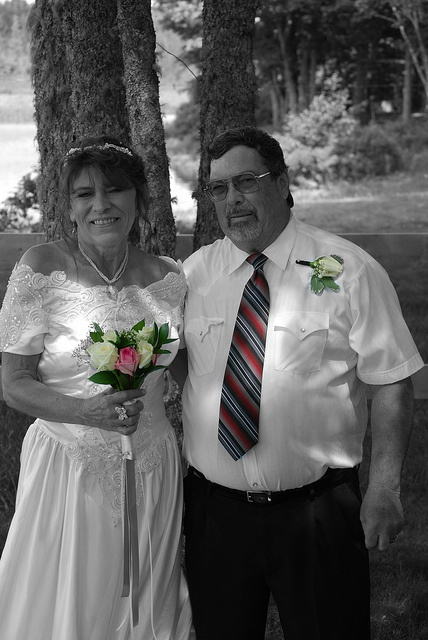Describe the objects in this image and their specific colors. I can see people in white, black, darkgray, gray, and lightgray tones, people in white, darkgray, gray, black, and lightgray tones, and tie in white, black, gray, maroon, and darkgray tones in this image. 